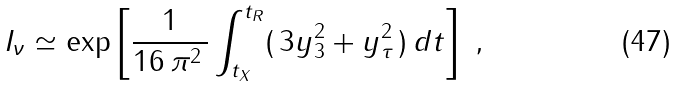<formula> <loc_0><loc_0><loc_500><loc_500>I _ { \nu } \simeq \exp \left [ \frac { 1 } { 1 6 \, \pi ^ { 2 } \, } \int _ { t _ { X } } ^ { t _ { R } } ( \, 3 y _ { 3 } ^ { 2 } + y _ { \tau } ^ { 2 } \, ) \, d t \right ] \ ,</formula> 